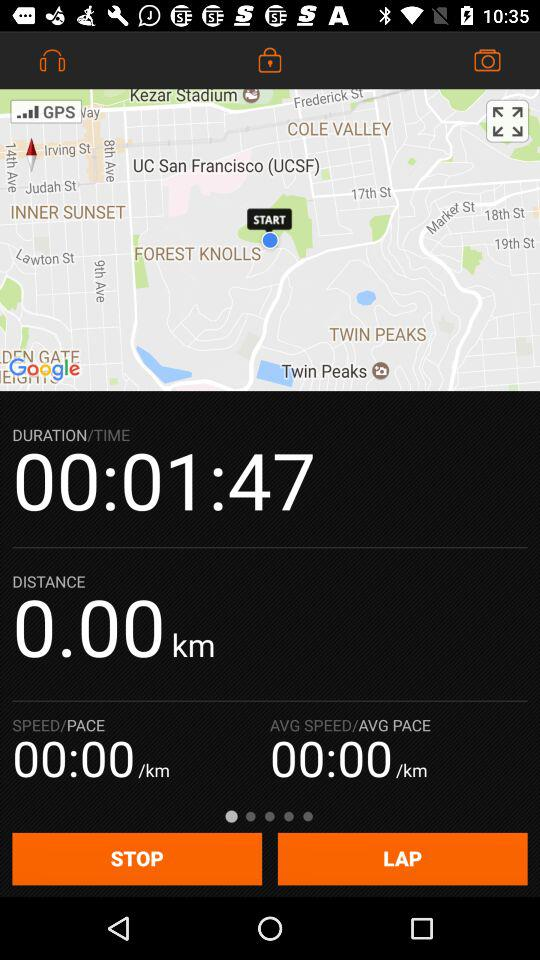How long has the user been running?
Answer the question using a single word or phrase. 00:01:47 